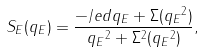Convert formula to latex. <formula><loc_0><loc_0><loc_500><loc_500>S _ { E } ( q _ { E } ) = \frac { - \slash e d { q } _ { E } + \Sigma ( { q _ { E } } ^ { 2 } ) } { { q _ { E } } ^ { 2 } + \Sigma ^ { 2 } ( { q _ { E } } ^ { 2 } ) } ,</formula> 